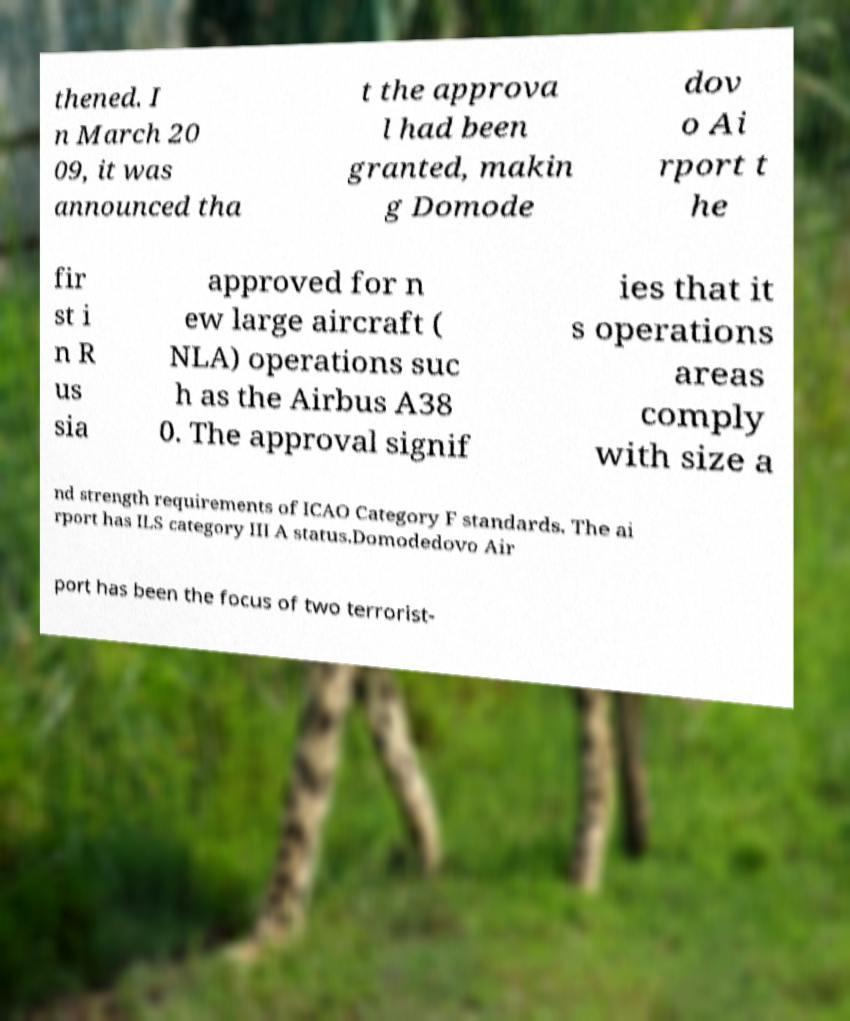There's text embedded in this image that I need extracted. Can you transcribe it verbatim? thened. I n March 20 09, it was announced tha t the approva l had been granted, makin g Domode dov o Ai rport t he fir st i n R us sia approved for n ew large aircraft ( NLA) operations suc h as the Airbus A38 0. The approval signif ies that it s operations areas comply with size a nd strength requirements of ICAO Category F standards. The ai rport has ILS category III A status.Domodedovo Air port has been the focus of two terrorist- 